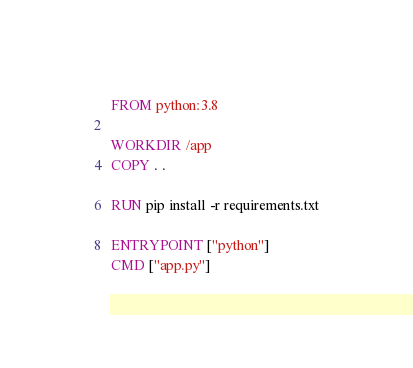<code> <loc_0><loc_0><loc_500><loc_500><_Dockerfile_>FROM python:3.8

WORKDIR /app
COPY . .

RUN pip install -r requirements.txt

ENTRYPOINT ["python"]
CMD ["app.py"]</code> 